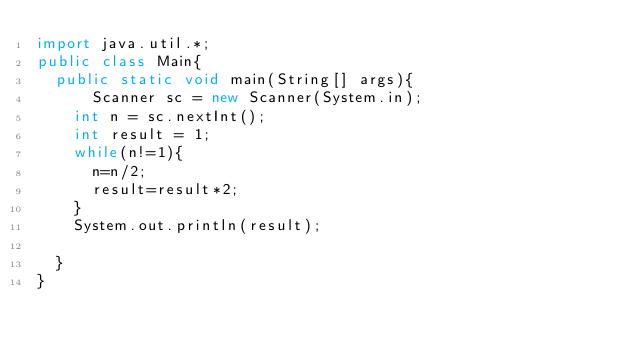Convert code to text. <code><loc_0><loc_0><loc_500><loc_500><_Java_>import java.util.*;
public class Main{
	public static void main(String[] args){
  		Scanner sc = new Scanner(System.in);
		int n = sc.nextInt();
		int result = 1;
		while(n!=1){
			n=n/2;
			result=result*2;
		}
		System.out.println(result);
		
	}
}
</code> 